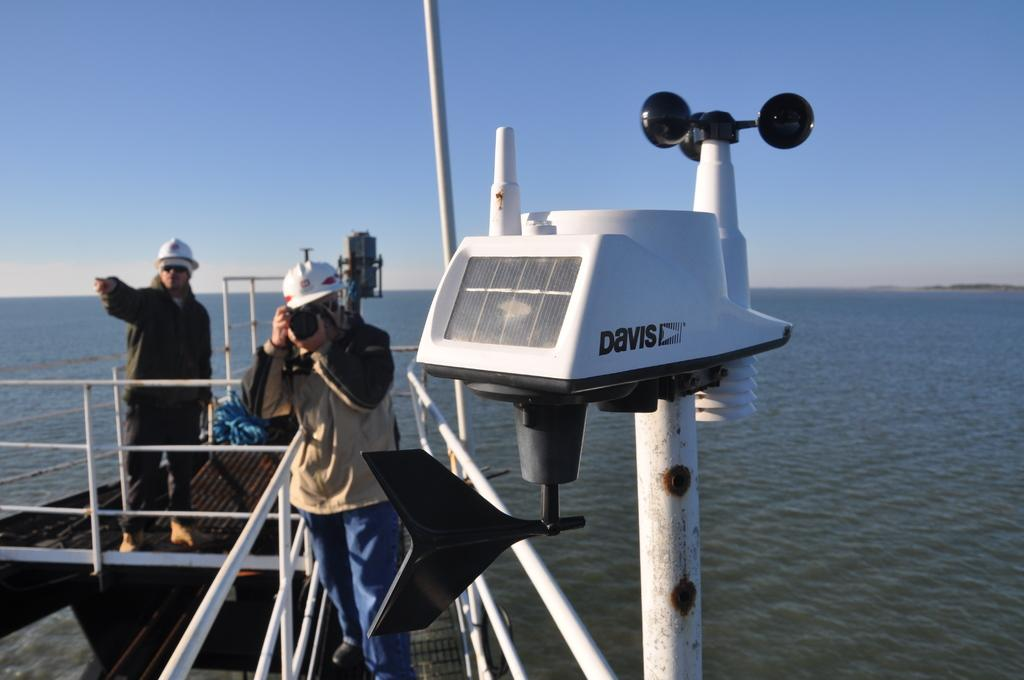<image>
Write a terse but informative summary of the picture. a boat with a label on a part of it that says 'davis' 